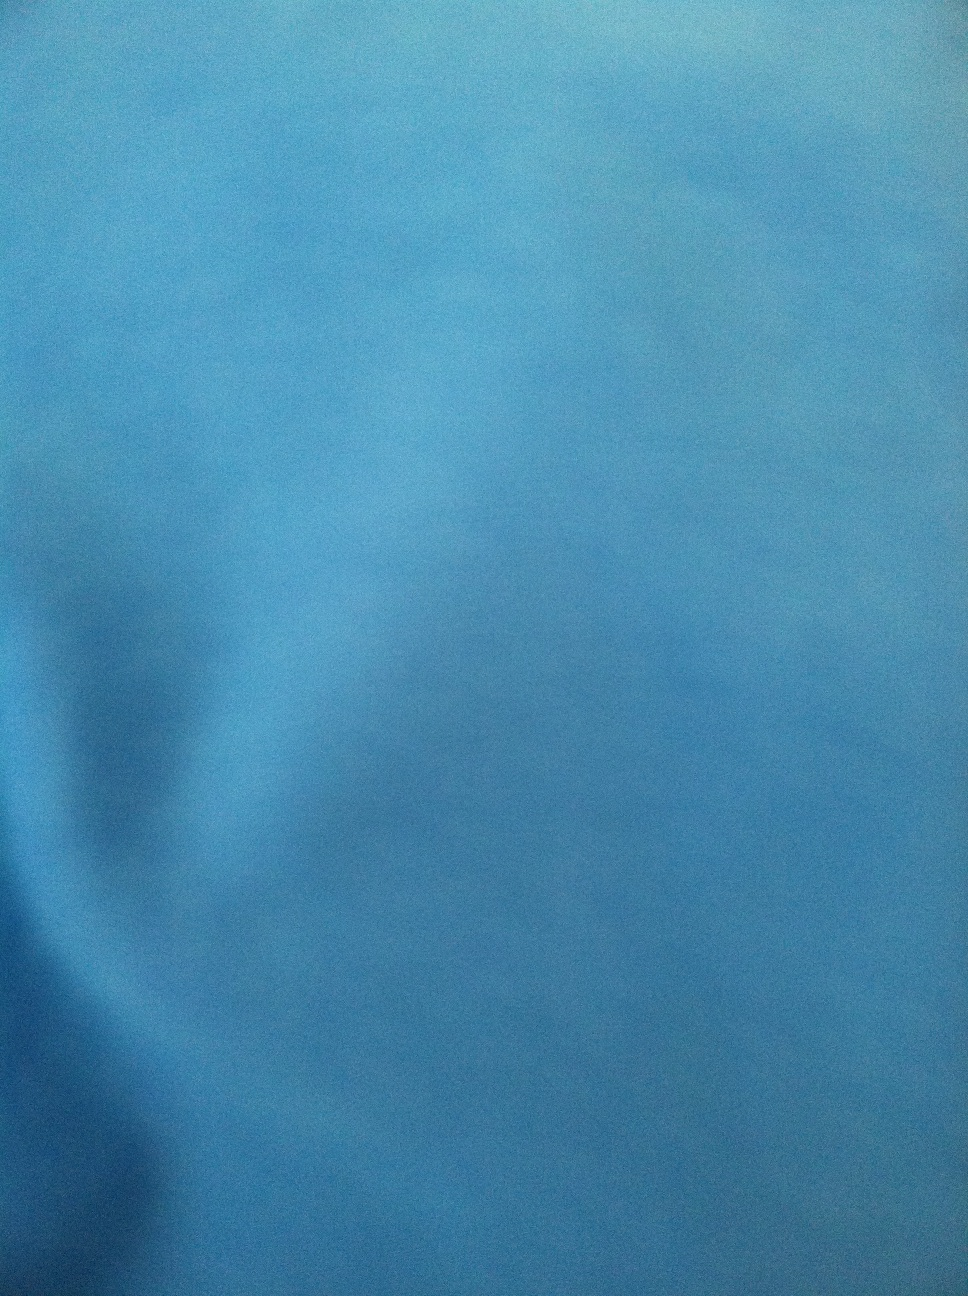How would you describe the texture or material of the dress based on the image? It's difficult to determine the exact texture or material from the image due to its lack of clarity. However, the surface appears somewhat smooth which might suggest a silky or satin-type material. It's best to physically feel the material for a precise description. 